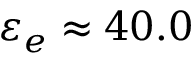Convert formula to latex. <formula><loc_0><loc_0><loc_500><loc_500>\varepsilon _ { e } \approx 4 0 . 0</formula> 